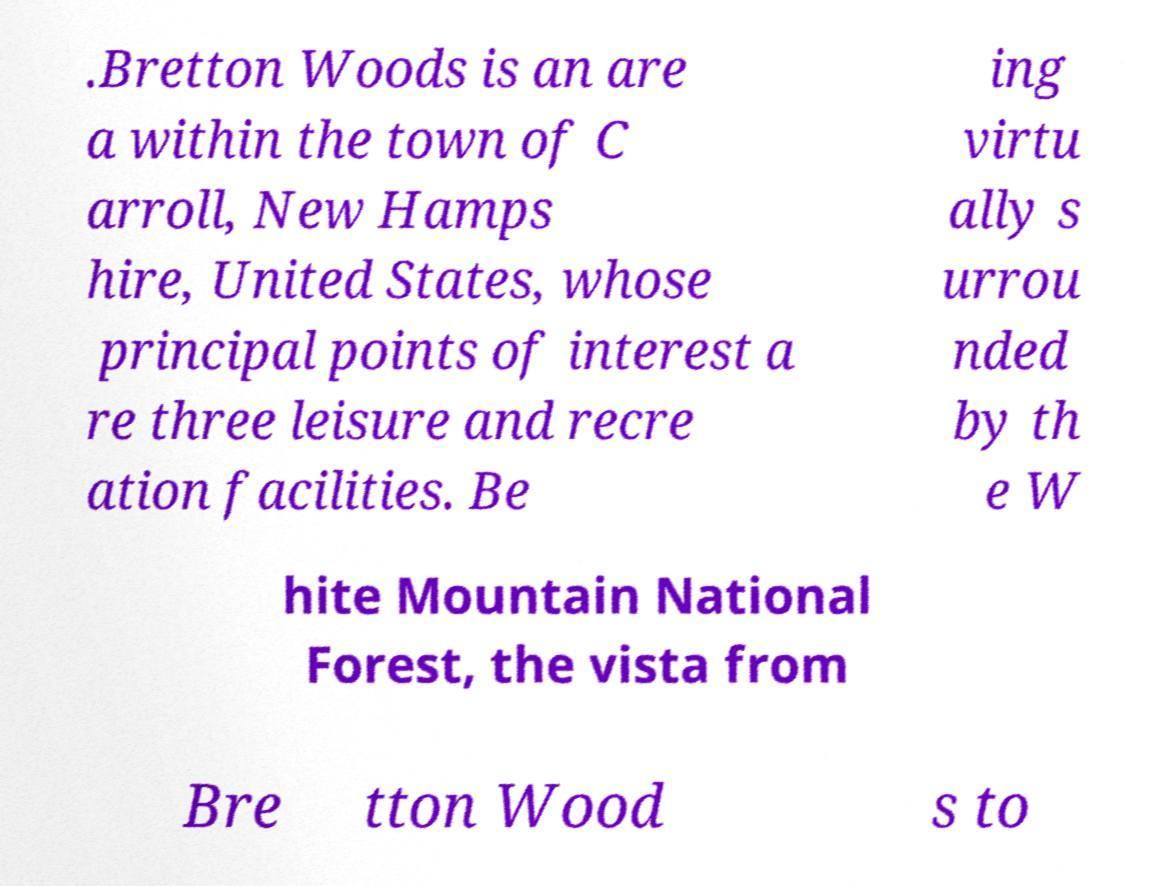Can you accurately transcribe the text from the provided image for me? .Bretton Woods is an are a within the town of C arroll, New Hamps hire, United States, whose principal points of interest a re three leisure and recre ation facilities. Be ing virtu ally s urrou nded by th e W hite Mountain National Forest, the vista from Bre tton Wood s to 